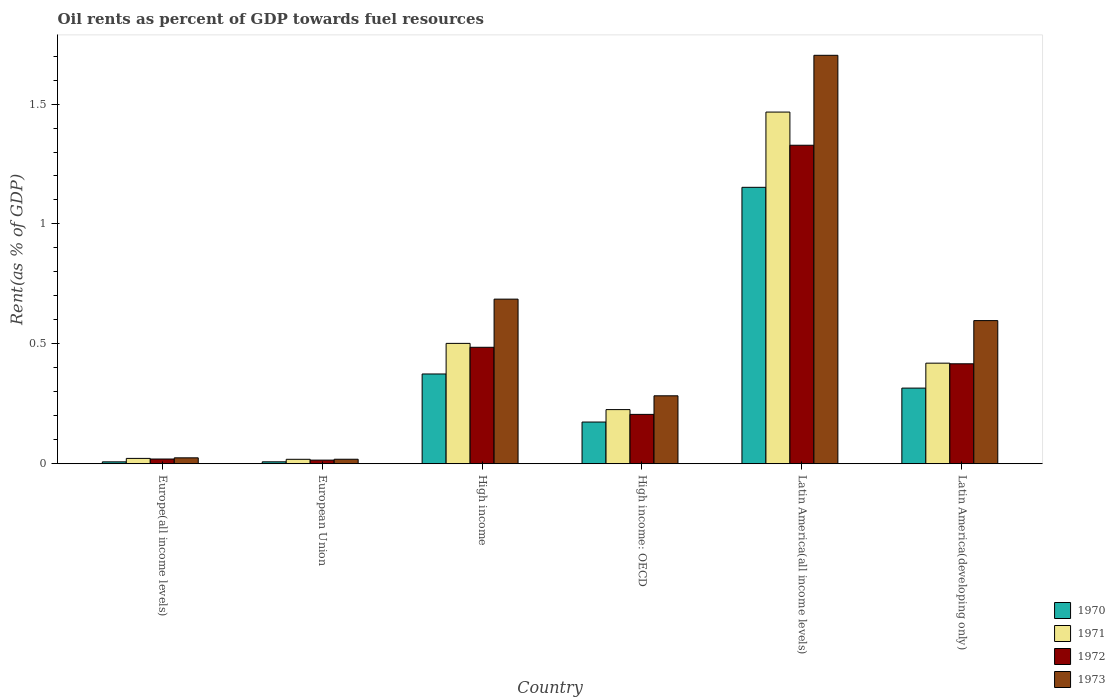How many bars are there on the 4th tick from the left?
Your response must be concise. 4. What is the label of the 1st group of bars from the left?
Offer a very short reply. Europe(all income levels). In how many cases, is the number of bars for a given country not equal to the number of legend labels?
Your answer should be compact. 0. What is the oil rent in 1973 in High income?
Your response must be concise. 0.69. Across all countries, what is the maximum oil rent in 1972?
Provide a short and direct response. 1.33. Across all countries, what is the minimum oil rent in 1973?
Make the answer very short. 0.02. In which country was the oil rent in 1973 maximum?
Give a very brief answer. Latin America(all income levels). In which country was the oil rent in 1973 minimum?
Your answer should be very brief. European Union. What is the total oil rent in 1971 in the graph?
Offer a terse response. 2.65. What is the difference between the oil rent in 1970 in High income: OECD and that in Latin America(developing only)?
Offer a terse response. -0.14. What is the difference between the oil rent in 1973 in Europe(all income levels) and the oil rent in 1970 in European Union?
Ensure brevity in your answer.  0.02. What is the average oil rent in 1970 per country?
Make the answer very short. 0.34. What is the difference between the oil rent of/in 1971 and oil rent of/in 1970 in Latin America(all income levels)?
Provide a short and direct response. 0.31. What is the ratio of the oil rent in 1973 in High income: OECD to that in Latin America(all income levels)?
Keep it short and to the point. 0.17. Is the oil rent in 1971 in European Union less than that in High income: OECD?
Provide a short and direct response. Yes. Is the difference between the oil rent in 1971 in High income and Latin America(all income levels) greater than the difference between the oil rent in 1970 in High income and Latin America(all income levels)?
Provide a short and direct response. No. What is the difference between the highest and the second highest oil rent in 1972?
Offer a terse response. -0.84. What is the difference between the highest and the lowest oil rent in 1970?
Offer a very short reply. 1.14. In how many countries, is the oil rent in 1970 greater than the average oil rent in 1970 taken over all countries?
Provide a short and direct response. 2. Is the sum of the oil rent in 1973 in High income: OECD and Latin America(developing only) greater than the maximum oil rent in 1971 across all countries?
Your answer should be very brief. No. Is it the case that in every country, the sum of the oil rent in 1972 and oil rent in 1970 is greater than the sum of oil rent in 1973 and oil rent in 1971?
Ensure brevity in your answer.  No. What does the 1st bar from the right in European Union represents?
Your answer should be compact. 1973. Is it the case that in every country, the sum of the oil rent in 1970 and oil rent in 1973 is greater than the oil rent in 1972?
Provide a short and direct response. Yes. How many bars are there?
Provide a succinct answer. 24. Are all the bars in the graph horizontal?
Offer a very short reply. No. How many countries are there in the graph?
Give a very brief answer. 6. What is the difference between two consecutive major ticks on the Y-axis?
Ensure brevity in your answer.  0.5. Does the graph contain any zero values?
Your answer should be very brief. No. Where does the legend appear in the graph?
Offer a very short reply. Bottom right. How many legend labels are there?
Your response must be concise. 4. How are the legend labels stacked?
Offer a terse response. Vertical. What is the title of the graph?
Your response must be concise. Oil rents as percent of GDP towards fuel resources. Does "1975" appear as one of the legend labels in the graph?
Offer a very short reply. No. What is the label or title of the X-axis?
Provide a short and direct response. Country. What is the label or title of the Y-axis?
Provide a succinct answer. Rent(as % of GDP). What is the Rent(as % of GDP) in 1970 in Europe(all income levels)?
Ensure brevity in your answer.  0.01. What is the Rent(as % of GDP) in 1971 in Europe(all income levels)?
Keep it short and to the point. 0.02. What is the Rent(as % of GDP) of 1972 in Europe(all income levels)?
Offer a very short reply. 0.02. What is the Rent(as % of GDP) in 1973 in Europe(all income levels)?
Your answer should be very brief. 0.02. What is the Rent(as % of GDP) in 1970 in European Union?
Give a very brief answer. 0.01. What is the Rent(as % of GDP) of 1971 in European Union?
Offer a terse response. 0.02. What is the Rent(as % of GDP) of 1972 in European Union?
Offer a very short reply. 0.02. What is the Rent(as % of GDP) in 1973 in European Union?
Ensure brevity in your answer.  0.02. What is the Rent(as % of GDP) of 1970 in High income?
Provide a short and direct response. 0.37. What is the Rent(as % of GDP) in 1971 in High income?
Provide a short and direct response. 0.5. What is the Rent(as % of GDP) in 1972 in High income?
Your answer should be very brief. 0.49. What is the Rent(as % of GDP) in 1973 in High income?
Offer a terse response. 0.69. What is the Rent(as % of GDP) in 1970 in High income: OECD?
Your response must be concise. 0.17. What is the Rent(as % of GDP) in 1971 in High income: OECD?
Offer a very short reply. 0.23. What is the Rent(as % of GDP) in 1972 in High income: OECD?
Provide a succinct answer. 0.21. What is the Rent(as % of GDP) in 1973 in High income: OECD?
Offer a very short reply. 0.28. What is the Rent(as % of GDP) of 1970 in Latin America(all income levels)?
Your answer should be very brief. 1.15. What is the Rent(as % of GDP) of 1971 in Latin America(all income levels)?
Ensure brevity in your answer.  1.47. What is the Rent(as % of GDP) of 1972 in Latin America(all income levels)?
Keep it short and to the point. 1.33. What is the Rent(as % of GDP) in 1973 in Latin America(all income levels)?
Your answer should be very brief. 1.7. What is the Rent(as % of GDP) of 1970 in Latin America(developing only)?
Provide a short and direct response. 0.32. What is the Rent(as % of GDP) in 1971 in Latin America(developing only)?
Your answer should be very brief. 0.42. What is the Rent(as % of GDP) in 1972 in Latin America(developing only)?
Keep it short and to the point. 0.42. What is the Rent(as % of GDP) in 1973 in Latin America(developing only)?
Offer a terse response. 0.6. Across all countries, what is the maximum Rent(as % of GDP) of 1970?
Offer a very short reply. 1.15. Across all countries, what is the maximum Rent(as % of GDP) of 1971?
Offer a terse response. 1.47. Across all countries, what is the maximum Rent(as % of GDP) in 1972?
Your answer should be very brief. 1.33. Across all countries, what is the maximum Rent(as % of GDP) of 1973?
Provide a succinct answer. 1.7. Across all countries, what is the minimum Rent(as % of GDP) in 1970?
Make the answer very short. 0.01. Across all countries, what is the minimum Rent(as % of GDP) in 1971?
Offer a terse response. 0.02. Across all countries, what is the minimum Rent(as % of GDP) of 1972?
Give a very brief answer. 0.02. Across all countries, what is the minimum Rent(as % of GDP) in 1973?
Your answer should be compact. 0.02. What is the total Rent(as % of GDP) of 1970 in the graph?
Your answer should be very brief. 2.03. What is the total Rent(as % of GDP) of 1971 in the graph?
Provide a short and direct response. 2.65. What is the total Rent(as % of GDP) of 1972 in the graph?
Provide a succinct answer. 2.47. What is the total Rent(as % of GDP) of 1973 in the graph?
Your answer should be very brief. 3.31. What is the difference between the Rent(as % of GDP) of 1970 in Europe(all income levels) and that in European Union?
Make the answer very short. -0. What is the difference between the Rent(as % of GDP) in 1971 in Europe(all income levels) and that in European Union?
Offer a very short reply. 0. What is the difference between the Rent(as % of GDP) in 1972 in Europe(all income levels) and that in European Union?
Provide a short and direct response. 0. What is the difference between the Rent(as % of GDP) of 1973 in Europe(all income levels) and that in European Union?
Provide a succinct answer. 0.01. What is the difference between the Rent(as % of GDP) of 1970 in Europe(all income levels) and that in High income?
Keep it short and to the point. -0.37. What is the difference between the Rent(as % of GDP) in 1971 in Europe(all income levels) and that in High income?
Make the answer very short. -0.48. What is the difference between the Rent(as % of GDP) in 1972 in Europe(all income levels) and that in High income?
Your answer should be very brief. -0.47. What is the difference between the Rent(as % of GDP) of 1973 in Europe(all income levels) and that in High income?
Your answer should be compact. -0.66. What is the difference between the Rent(as % of GDP) of 1970 in Europe(all income levels) and that in High income: OECD?
Your response must be concise. -0.17. What is the difference between the Rent(as % of GDP) in 1971 in Europe(all income levels) and that in High income: OECD?
Keep it short and to the point. -0.2. What is the difference between the Rent(as % of GDP) in 1972 in Europe(all income levels) and that in High income: OECD?
Offer a terse response. -0.19. What is the difference between the Rent(as % of GDP) of 1973 in Europe(all income levels) and that in High income: OECD?
Make the answer very short. -0.26. What is the difference between the Rent(as % of GDP) of 1970 in Europe(all income levels) and that in Latin America(all income levels)?
Make the answer very short. -1.14. What is the difference between the Rent(as % of GDP) of 1971 in Europe(all income levels) and that in Latin America(all income levels)?
Your answer should be compact. -1.44. What is the difference between the Rent(as % of GDP) of 1972 in Europe(all income levels) and that in Latin America(all income levels)?
Your answer should be very brief. -1.31. What is the difference between the Rent(as % of GDP) in 1973 in Europe(all income levels) and that in Latin America(all income levels)?
Your response must be concise. -1.68. What is the difference between the Rent(as % of GDP) of 1970 in Europe(all income levels) and that in Latin America(developing only)?
Keep it short and to the point. -0.31. What is the difference between the Rent(as % of GDP) of 1971 in Europe(all income levels) and that in Latin America(developing only)?
Provide a short and direct response. -0.4. What is the difference between the Rent(as % of GDP) of 1972 in Europe(all income levels) and that in Latin America(developing only)?
Provide a short and direct response. -0.4. What is the difference between the Rent(as % of GDP) of 1973 in Europe(all income levels) and that in Latin America(developing only)?
Make the answer very short. -0.57. What is the difference between the Rent(as % of GDP) of 1970 in European Union and that in High income?
Make the answer very short. -0.37. What is the difference between the Rent(as % of GDP) in 1971 in European Union and that in High income?
Provide a short and direct response. -0.48. What is the difference between the Rent(as % of GDP) in 1972 in European Union and that in High income?
Give a very brief answer. -0.47. What is the difference between the Rent(as % of GDP) of 1973 in European Union and that in High income?
Provide a short and direct response. -0.67. What is the difference between the Rent(as % of GDP) of 1970 in European Union and that in High income: OECD?
Keep it short and to the point. -0.17. What is the difference between the Rent(as % of GDP) of 1971 in European Union and that in High income: OECD?
Ensure brevity in your answer.  -0.21. What is the difference between the Rent(as % of GDP) of 1972 in European Union and that in High income: OECD?
Offer a terse response. -0.19. What is the difference between the Rent(as % of GDP) of 1973 in European Union and that in High income: OECD?
Give a very brief answer. -0.26. What is the difference between the Rent(as % of GDP) of 1970 in European Union and that in Latin America(all income levels)?
Make the answer very short. -1.14. What is the difference between the Rent(as % of GDP) in 1971 in European Union and that in Latin America(all income levels)?
Provide a succinct answer. -1.45. What is the difference between the Rent(as % of GDP) of 1972 in European Union and that in Latin America(all income levels)?
Offer a very short reply. -1.31. What is the difference between the Rent(as % of GDP) of 1973 in European Union and that in Latin America(all income levels)?
Give a very brief answer. -1.68. What is the difference between the Rent(as % of GDP) of 1970 in European Union and that in Latin America(developing only)?
Provide a short and direct response. -0.31. What is the difference between the Rent(as % of GDP) in 1971 in European Union and that in Latin America(developing only)?
Your answer should be compact. -0.4. What is the difference between the Rent(as % of GDP) of 1972 in European Union and that in Latin America(developing only)?
Provide a short and direct response. -0.4. What is the difference between the Rent(as % of GDP) in 1973 in European Union and that in Latin America(developing only)?
Your response must be concise. -0.58. What is the difference between the Rent(as % of GDP) in 1970 in High income and that in High income: OECD?
Provide a succinct answer. 0.2. What is the difference between the Rent(as % of GDP) of 1971 in High income and that in High income: OECD?
Provide a short and direct response. 0.28. What is the difference between the Rent(as % of GDP) of 1972 in High income and that in High income: OECD?
Make the answer very short. 0.28. What is the difference between the Rent(as % of GDP) of 1973 in High income and that in High income: OECD?
Your answer should be compact. 0.4. What is the difference between the Rent(as % of GDP) in 1970 in High income and that in Latin America(all income levels)?
Your answer should be compact. -0.78. What is the difference between the Rent(as % of GDP) of 1971 in High income and that in Latin America(all income levels)?
Provide a succinct answer. -0.96. What is the difference between the Rent(as % of GDP) in 1972 in High income and that in Latin America(all income levels)?
Give a very brief answer. -0.84. What is the difference between the Rent(as % of GDP) of 1973 in High income and that in Latin America(all income levels)?
Offer a terse response. -1.02. What is the difference between the Rent(as % of GDP) of 1970 in High income and that in Latin America(developing only)?
Provide a succinct answer. 0.06. What is the difference between the Rent(as % of GDP) of 1971 in High income and that in Latin America(developing only)?
Ensure brevity in your answer.  0.08. What is the difference between the Rent(as % of GDP) of 1972 in High income and that in Latin America(developing only)?
Your answer should be compact. 0.07. What is the difference between the Rent(as % of GDP) of 1973 in High income and that in Latin America(developing only)?
Make the answer very short. 0.09. What is the difference between the Rent(as % of GDP) in 1970 in High income: OECD and that in Latin America(all income levels)?
Keep it short and to the point. -0.98. What is the difference between the Rent(as % of GDP) of 1971 in High income: OECD and that in Latin America(all income levels)?
Make the answer very short. -1.24. What is the difference between the Rent(as % of GDP) of 1972 in High income: OECD and that in Latin America(all income levels)?
Keep it short and to the point. -1.12. What is the difference between the Rent(as % of GDP) in 1973 in High income: OECD and that in Latin America(all income levels)?
Ensure brevity in your answer.  -1.42. What is the difference between the Rent(as % of GDP) of 1970 in High income: OECD and that in Latin America(developing only)?
Offer a terse response. -0.14. What is the difference between the Rent(as % of GDP) of 1971 in High income: OECD and that in Latin America(developing only)?
Your answer should be compact. -0.19. What is the difference between the Rent(as % of GDP) of 1972 in High income: OECD and that in Latin America(developing only)?
Provide a short and direct response. -0.21. What is the difference between the Rent(as % of GDP) in 1973 in High income: OECD and that in Latin America(developing only)?
Ensure brevity in your answer.  -0.31. What is the difference between the Rent(as % of GDP) of 1970 in Latin America(all income levels) and that in Latin America(developing only)?
Provide a short and direct response. 0.84. What is the difference between the Rent(as % of GDP) of 1971 in Latin America(all income levels) and that in Latin America(developing only)?
Your answer should be very brief. 1.05. What is the difference between the Rent(as % of GDP) in 1972 in Latin America(all income levels) and that in Latin America(developing only)?
Give a very brief answer. 0.91. What is the difference between the Rent(as % of GDP) in 1973 in Latin America(all income levels) and that in Latin America(developing only)?
Your answer should be compact. 1.11. What is the difference between the Rent(as % of GDP) in 1970 in Europe(all income levels) and the Rent(as % of GDP) in 1971 in European Union?
Your answer should be very brief. -0.01. What is the difference between the Rent(as % of GDP) in 1970 in Europe(all income levels) and the Rent(as % of GDP) in 1972 in European Union?
Provide a short and direct response. -0.01. What is the difference between the Rent(as % of GDP) in 1970 in Europe(all income levels) and the Rent(as % of GDP) in 1973 in European Union?
Keep it short and to the point. -0.01. What is the difference between the Rent(as % of GDP) in 1971 in Europe(all income levels) and the Rent(as % of GDP) in 1972 in European Union?
Your answer should be very brief. 0.01. What is the difference between the Rent(as % of GDP) in 1971 in Europe(all income levels) and the Rent(as % of GDP) in 1973 in European Union?
Give a very brief answer. 0. What is the difference between the Rent(as % of GDP) of 1972 in Europe(all income levels) and the Rent(as % of GDP) of 1973 in European Union?
Offer a terse response. 0. What is the difference between the Rent(as % of GDP) of 1970 in Europe(all income levels) and the Rent(as % of GDP) of 1971 in High income?
Provide a short and direct response. -0.49. What is the difference between the Rent(as % of GDP) in 1970 in Europe(all income levels) and the Rent(as % of GDP) in 1972 in High income?
Offer a very short reply. -0.48. What is the difference between the Rent(as % of GDP) in 1970 in Europe(all income levels) and the Rent(as % of GDP) in 1973 in High income?
Your response must be concise. -0.68. What is the difference between the Rent(as % of GDP) of 1971 in Europe(all income levels) and the Rent(as % of GDP) of 1972 in High income?
Make the answer very short. -0.46. What is the difference between the Rent(as % of GDP) of 1971 in Europe(all income levels) and the Rent(as % of GDP) of 1973 in High income?
Offer a terse response. -0.66. What is the difference between the Rent(as % of GDP) of 1972 in Europe(all income levels) and the Rent(as % of GDP) of 1973 in High income?
Provide a short and direct response. -0.67. What is the difference between the Rent(as % of GDP) in 1970 in Europe(all income levels) and the Rent(as % of GDP) in 1971 in High income: OECD?
Provide a succinct answer. -0.22. What is the difference between the Rent(as % of GDP) in 1970 in Europe(all income levels) and the Rent(as % of GDP) in 1972 in High income: OECD?
Your answer should be very brief. -0.2. What is the difference between the Rent(as % of GDP) in 1970 in Europe(all income levels) and the Rent(as % of GDP) in 1973 in High income: OECD?
Ensure brevity in your answer.  -0.28. What is the difference between the Rent(as % of GDP) of 1971 in Europe(all income levels) and the Rent(as % of GDP) of 1972 in High income: OECD?
Provide a short and direct response. -0.18. What is the difference between the Rent(as % of GDP) in 1971 in Europe(all income levels) and the Rent(as % of GDP) in 1973 in High income: OECD?
Provide a succinct answer. -0.26. What is the difference between the Rent(as % of GDP) of 1972 in Europe(all income levels) and the Rent(as % of GDP) of 1973 in High income: OECD?
Provide a succinct answer. -0.26. What is the difference between the Rent(as % of GDP) of 1970 in Europe(all income levels) and the Rent(as % of GDP) of 1971 in Latin America(all income levels)?
Offer a very short reply. -1.46. What is the difference between the Rent(as % of GDP) of 1970 in Europe(all income levels) and the Rent(as % of GDP) of 1972 in Latin America(all income levels)?
Your answer should be compact. -1.32. What is the difference between the Rent(as % of GDP) of 1970 in Europe(all income levels) and the Rent(as % of GDP) of 1973 in Latin America(all income levels)?
Offer a very short reply. -1.7. What is the difference between the Rent(as % of GDP) in 1971 in Europe(all income levels) and the Rent(as % of GDP) in 1972 in Latin America(all income levels)?
Provide a short and direct response. -1.31. What is the difference between the Rent(as % of GDP) of 1971 in Europe(all income levels) and the Rent(as % of GDP) of 1973 in Latin America(all income levels)?
Your response must be concise. -1.68. What is the difference between the Rent(as % of GDP) of 1972 in Europe(all income levels) and the Rent(as % of GDP) of 1973 in Latin America(all income levels)?
Give a very brief answer. -1.68. What is the difference between the Rent(as % of GDP) of 1970 in Europe(all income levels) and the Rent(as % of GDP) of 1971 in Latin America(developing only)?
Provide a short and direct response. -0.41. What is the difference between the Rent(as % of GDP) of 1970 in Europe(all income levels) and the Rent(as % of GDP) of 1972 in Latin America(developing only)?
Ensure brevity in your answer.  -0.41. What is the difference between the Rent(as % of GDP) of 1970 in Europe(all income levels) and the Rent(as % of GDP) of 1973 in Latin America(developing only)?
Provide a short and direct response. -0.59. What is the difference between the Rent(as % of GDP) in 1971 in Europe(all income levels) and the Rent(as % of GDP) in 1972 in Latin America(developing only)?
Your answer should be compact. -0.39. What is the difference between the Rent(as % of GDP) of 1971 in Europe(all income levels) and the Rent(as % of GDP) of 1973 in Latin America(developing only)?
Ensure brevity in your answer.  -0.57. What is the difference between the Rent(as % of GDP) in 1972 in Europe(all income levels) and the Rent(as % of GDP) in 1973 in Latin America(developing only)?
Offer a very short reply. -0.58. What is the difference between the Rent(as % of GDP) of 1970 in European Union and the Rent(as % of GDP) of 1971 in High income?
Offer a terse response. -0.49. What is the difference between the Rent(as % of GDP) of 1970 in European Union and the Rent(as % of GDP) of 1972 in High income?
Your answer should be compact. -0.48. What is the difference between the Rent(as % of GDP) of 1970 in European Union and the Rent(as % of GDP) of 1973 in High income?
Make the answer very short. -0.68. What is the difference between the Rent(as % of GDP) in 1971 in European Union and the Rent(as % of GDP) in 1972 in High income?
Offer a terse response. -0.47. What is the difference between the Rent(as % of GDP) of 1971 in European Union and the Rent(as % of GDP) of 1973 in High income?
Provide a succinct answer. -0.67. What is the difference between the Rent(as % of GDP) in 1972 in European Union and the Rent(as % of GDP) in 1973 in High income?
Ensure brevity in your answer.  -0.67. What is the difference between the Rent(as % of GDP) of 1970 in European Union and the Rent(as % of GDP) of 1971 in High income: OECD?
Provide a short and direct response. -0.22. What is the difference between the Rent(as % of GDP) of 1970 in European Union and the Rent(as % of GDP) of 1972 in High income: OECD?
Give a very brief answer. -0.2. What is the difference between the Rent(as % of GDP) of 1970 in European Union and the Rent(as % of GDP) of 1973 in High income: OECD?
Your answer should be very brief. -0.28. What is the difference between the Rent(as % of GDP) in 1971 in European Union and the Rent(as % of GDP) in 1972 in High income: OECD?
Offer a very short reply. -0.19. What is the difference between the Rent(as % of GDP) in 1971 in European Union and the Rent(as % of GDP) in 1973 in High income: OECD?
Ensure brevity in your answer.  -0.26. What is the difference between the Rent(as % of GDP) of 1972 in European Union and the Rent(as % of GDP) of 1973 in High income: OECD?
Your answer should be compact. -0.27. What is the difference between the Rent(as % of GDP) of 1970 in European Union and the Rent(as % of GDP) of 1971 in Latin America(all income levels)?
Keep it short and to the point. -1.46. What is the difference between the Rent(as % of GDP) in 1970 in European Union and the Rent(as % of GDP) in 1972 in Latin America(all income levels)?
Your answer should be very brief. -1.32. What is the difference between the Rent(as % of GDP) in 1970 in European Union and the Rent(as % of GDP) in 1973 in Latin America(all income levels)?
Provide a succinct answer. -1.7. What is the difference between the Rent(as % of GDP) of 1971 in European Union and the Rent(as % of GDP) of 1972 in Latin America(all income levels)?
Your answer should be very brief. -1.31. What is the difference between the Rent(as % of GDP) of 1971 in European Union and the Rent(as % of GDP) of 1973 in Latin America(all income levels)?
Your response must be concise. -1.68. What is the difference between the Rent(as % of GDP) of 1972 in European Union and the Rent(as % of GDP) of 1973 in Latin America(all income levels)?
Offer a terse response. -1.69. What is the difference between the Rent(as % of GDP) in 1970 in European Union and the Rent(as % of GDP) in 1971 in Latin America(developing only)?
Offer a very short reply. -0.41. What is the difference between the Rent(as % of GDP) in 1970 in European Union and the Rent(as % of GDP) in 1972 in Latin America(developing only)?
Provide a succinct answer. -0.41. What is the difference between the Rent(as % of GDP) in 1970 in European Union and the Rent(as % of GDP) in 1973 in Latin America(developing only)?
Make the answer very short. -0.59. What is the difference between the Rent(as % of GDP) of 1971 in European Union and the Rent(as % of GDP) of 1972 in Latin America(developing only)?
Provide a succinct answer. -0.4. What is the difference between the Rent(as % of GDP) in 1971 in European Union and the Rent(as % of GDP) in 1973 in Latin America(developing only)?
Your answer should be compact. -0.58. What is the difference between the Rent(as % of GDP) of 1972 in European Union and the Rent(as % of GDP) of 1973 in Latin America(developing only)?
Give a very brief answer. -0.58. What is the difference between the Rent(as % of GDP) in 1970 in High income and the Rent(as % of GDP) in 1971 in High income: OECD?
Keep it short and to the point. 0.15. What is the difference between the Rent(as % of GDP) in 1970 in High income and the Rent(as % of GDP) in 1972 in High income: OECD?
Your response must be concise. 0.17. What is the difference between the Rent(as % of GDP) of 1970 in High income and the Rent(as % of GDP) of 1973 in High income: OECD?
Keep it short and to the point. 0.09. What is the difference between the Rent(as % of GDP) in 1971 in High income and the Rent(as % of GDP) in 1972 in High income: OECD?
Provide a succinct answer. 0.3. What is the difference between the Rent(as % of GDP) in 1971 in High income and the Rent(as % of GDP) in 1973 in High income: OECD?
Ensure brevity in your answer.  0.22. What is the difference between the Rent(as % of GDP) in 1972 in High income and the Rent(as % of GDP) in 1973 in High income: OECD?
Your answer should be very brief. 0.2. What is the difference between the Rent(as % of GDP) of 1970 in High income and the Rent(as % of GDP) of 1971 in Latin America(all income levels)?
Your response must be concise. -1.09. What is the difference between the Rent(as % of GDP) of 1970 in High income and the Rent(as % of GDP) of 1972 in Latin America(all income levels)?
Offer a terse response. -0.95. What is the difference between the Rent(as % of GDP) in 1970 in High income and the Rent(as % of GDP) in 1973 in Latin America(all income levels)?
Offer a very short reply. -1.33. What is the difference between the Rent(as % of GDP) of 1971 in High income and the Rent(as % of GDP) of 1972 in Latin America(all income levels)?
Offer a very short reply. -0.83. What is the difference between the Rent(as % of GDP) of 1971 in High income and the Rent(as % of GDP) of 1973 in Latin America(all income levels)?
Provide a short and direct response. -1.2. What is the difference between the Rent(as % of GDP) of 1972 in High income and the Rent(as % of GDP) of 1973 in Latin America(all income levels)?
Provide a succinct answer. -1.22. What is the difference between the Rent(as % of GDP) of 1970 in High income and the Rent(as % of GDP) of 1971 in Latin America(developing only)?
Keep it short and to the point. -0.05. What is the difference between the Rent(as % of GDP) in 1970 in High income and the Rent(as % of GDP) in 1972 in Latin America(developing only)?
Make the answer very short. -0.04. What is the difference between the Rent(as % of GDP) in 1970 in High income and the Rent(as % of GDP) in 1973 in Latin America(developing only)?
Your answer should be very brief. -0.22. What is the difference between the Rent(as % of GDP) of 1971 in High income and the Rent(as % of GDP) of 1972 in Latin America(developing only)?
Keep it short and to the point. 0.09. What is the difference between the Rent(as % of GDP) in 1971 in High income and the Rent(as % of GDP) in 1973 in Latin America(developing only)?
Keep it short and to the point. -0.1. What is the difference between the Rent(as % of GDP) in 1972 in High income and the Rent(as % of GDP) in 1973 in Latin America(developing only)?
Give a very brief answer. -0.11. What is the difference between the Rent(as % of GDP) of 1970 in High income: OECD and the Rent(as % of GDP) of 1971 in Latin America(all income levels)?
Offer a very short reply. -1.29. What is the difference between the Rent(as % of GDP) in 1970 in High income: OECD and the Rent(as % of GDP) in 1972 in Latin America(all income levels)?
Your answer should be very brief. -1.15. What is the difference between the Rent(as % of GDP) in 1970 in High income: OECD and the Rent(as % of GDP) in 1973 in Latin America(all income levels)?
Keep it short and to the point. -1.53. What is the difference between the Rent(as % of GDP) in 1971 in High income: OECD and the Rent(as % of GDP) in 1972 in Latin America(all income levels)?
Make the answer very short. -1.1. What is the difference between the Rent(as % of GDP) of 1971 in High income: OECD and the Rent(as % of GDP) of 1973 in Latin America(all income levels)?
Your answer should be very brief. -1.48. What is the difference between the Rent(as % of GDP) of 1972 in High income: OECD and the Rent(as % of GDP) of 1973 in Latin America(all income levels)?
Provide a short and direct response. -1.5. What is the difference between the Rent(as % of GDP) in 1970 in High income: OECD and the Rent(as % of GDP) in 1971 in Latin America(developing only)?
Your response must be concise. -0.25. What is the difference between the Rent(as % of GDP) of 1970 in High income: OECD and the Rent(as % of GDP) of 1972 in Latin America(developing only)?
Your answer should be compact. -0.24. What is the difference between the Rent(as % of GDP) of 1970 in High income: OECD and the Rent(as % of GDP) of 1973 in Latin America(developing only)?
Your response must be concise. -0.42. What is the difference between the Rent(as % of GDP) in 1971 in High income: OECD and the Rent(as % of GDP) in 1972 in Latin America(developing only)?
Offer a very short reply. -0.19. What is the difference between the Rent(as % of GDP) of 1971 in High income: OECD and the Rent(as % of GDP) of 1973 in Latin America(developing only)?
Give a very brief answer. -0.37. What is the difference between the Rent(as % of GDP) of 1972 in High income: OECD and the Rent(as % of GDP) of 1973 in Latin America(developing only)?
Your answer should be compact. -0.39. What is the difference between the Rent(as % of GDP) in 1970 in Latin America(all income levels) and the Rent(as % of GDP) in 1971 in Latin America(developing only)?
Your response must be concise. 0.73. What is the difference between the Rent(as % of GDP) of 1970 in Latin America(all income levels) and the Rent(as % of GDP) of 1972 in Latin America(developing only)?
Offer a very short reply. 0.74. What is the difference between the Rent(as % of GDP) in 1970 in Latin America(all income levels) and the Rent(as % of GDP) in 1973 in Latin America(developing only)?
Offer a very short reply. 0.56. What is the difference between the Rent(as % of GDP) in 1971 in Latin America(all income levels) and the Rent(as % of GDP) in 1972 in Latin America(developing only)?
Offer a very short reply. 1.05. What is the difference between the Rent(as % of GDP) of 1971 in Latin America(all income levels) and the Rent(as % of GDP) of 1973 in Latin America(developing only)?
Give a very brief answer. 0.87. What is the difference between the Rent(as % of GDP) of 1972 in Latin America(all income levels) and the Rent(as % of GDP) of 1973 in Latin America(developing only)?
Give a very brief answer. 0.73. What is the average Rent(as % of GDP) in 1970 per country?
Offer a very short reply. 0.34. What is the average Rent(as % of GDP) in 1971 per country?
Give a very brief answer. 0.44. What is the average Rent(as % of GDP) in 1972 per country?
Keep it short and to the point. 0.41. What is the average Rent(as % of GDP) in 1973 per country?
Offer a terse response. 0.55. What is the difference between the Rent(as % of GDP) of 1970 and Rent(as % of GDP) of 1971 in Europe(all income levels)?
Provide a succinct answer. -0.01. What is the difference between the Rent(as % of GDP) of 1970 and Rent(as % of GDP) of 1972 in Europe(all income levels)?
Give a very brief answer. -0.01. What is the difference between the Rent(as % of GDP) in 1970 and Rent(as % of GDP) in 1973 in Europe(all income levels)?
Make the answer very short. -0.02. What is the difference between the Rent(as % of GDP) of 1971 and Rent(as % of GDP) of 1972 in Europe(all income levels)?
Your answer should be very brief. 0. What is the difference between the Rent(as % of GDP) of 1971 and Rent(as % of GDP) of 1973 in Europe(all income levels)?
Offer a terse response. -0. What is the difference between the Rent(as % of GDP) of 1972 and Rent(as % of GDP) of 1973 in Europe(all income levels)?
Provide a short and direct response. -0.01. What is the difference between the Rent(as % of GDP) in 1970 and Rent(as % of GDP) in 1971 in European Union?
Keep it short and to the point. -0.01. What is the difference between the Rent(as % of GDP) in 1970 and Rent(as % of GDP) in 1972 in European Union?
Offer a very short reply. -0.01. What is the difference between the Rent(as % of GDP) of 1970 and Rent(as % of GDP) of 1973 in European Union?
Ensure brevity in your answer.  -0.01. What is the difference between the Rent(as % of GDP) in 1971 and Rent(as % of GDP) in 1972 in European Union?
Your answer should be very brief. 0. What is the difference between the Rent(as % of GDP) of 1971 and Rent(as % of GDP) of 1973 in European Union?
Ensure brevity in your answer.  -0. What is the difference between the Rent(as % of GDP) of 1972 and Rent(as % of GDP) of 1973 in European Union?
Your answer should be compact. -0. What is the difference between the Rent(as % of GDP) in 1970 and Rent(as % of GDP) in 1971 in High income?
Provide a succinct answer. -0.13. What is the difference between the Rent(as % of GDP) in 1970 and Rent(as % of GDP) in 1972 in High income?
Make the answer very short. -0.11. What is the difference between the Rent(as % of GDP) of 1970 and Rent(as % of GDP) of 1973 in High income?
Ensure brevity in your answer.  -0.31. What is the difference between the Rent(as % of GDP) in 1971 and Rent(as % of GDP) in 1972 in High income?
Give a very brief answer. 0.02. What is the difference between the Rent(as % of GDP) of 1971 and Rent(as % of GDP) of 1973 in High income?
Provide a succinct answer. -0.18. What is the difference between the Rent(as % of GDP) in 1972 and Rent(as % of GDP) in 1973 in High income?
Offer a terse response. -0.2. What is the difference between the Rent(as % of GDP) in 1970 and Rent(as % of GDP) in 1971 in High income: OECD?
Provide a succinct answer. -0.05. What is the difference between the Rent(as % of GDP) of 1970 and Rent(as % of GDP) of 1972 in High income: OECD?
Your response must be concise. -0.03. What is the difference between the Rent(as % of GDP) of 1970 and Rent(as % of GDP) of 1973 in High income: OECD?
Provide a succinct answer. -0.11. What is the difference between the Rent(as % of GDP) of 1971 and Rent(as % of GDP) of 1973 in High income: OECD?
Your response must be concise. -0.06. What is the difference between the Rent(as % of GDP) in 1972 and Rent(as % of GDP) in 1973 in High income: OECD?
Provide a short and direct response. -0.08. What is the difference between the Rent(as % of GDP) in 1970 and Rent(as % of GDP) in 1971 in Latin America(all income levels)?
Offer a terse response. -0.31. What is the difference between the Rent(as % of GDP) of 1970 and Rent(as % of GDP) of 1972 in Latin America(all income levels)?
Make the answer very short. -0.18. What is the difference between the Rent(as % of GDP) in 1970 and Rent(as % of GDP) in 1973 in Latin America(all income levels)?
Offer a very short reply. -0.55. What is the difference between the Rent(as % of GDP) in 1971 and Rent(as % of GDP) in 1972 in Latin America(all income levels)?
Keep it short and to the point. 0.14. What is the difference between the Rent(as % of GDP) in 1971 and Rent(as % of GDP) in 1973 in Latin America(all income levels)?
Make the answer very short. -0.24. What is the difference between the Rent(as % of GDP) in 1972 and Rent(as % of GDP) in 1973 in Latin America(all income levels)?
Offer a terse response. -0.38. What is the difference between the Rent(as % of GDP) of 1970 and Rent(as % of GDP) of 1971 in Latin America(developing only)?
Make the answer very short. -0.1. What is the difference between the Rent(as % of GDP) in 1970 and Rent(as % of GDP) in 1972 in Latin America(developing only)?
Ensure brevity in your answer.  -0.1. What is the difference between the Rent(as % of GDP) in 1970 and Rent(as % of GDP) in 1973 in Latin America(developing only)?
Your response must be concise. -0.28. What is the difference between the Rent(as % of GDP) of 1971 and Rent(as % of GDP) of 1972 in Latin America(developing only)?
Provide a succinct answer. 0. What is the difference between the Rent(as % of GDP) of 1971 and Rent(as % of GDP) of 1973 in Latin America(developing only)?
Offer a terse response. -0.18. What is the difference between the Rent(as % of GDP) of 1972 and Rent(as % of GDP) of 1973 in Latin America(developing only)?
Provide a short and direct response. -0.18. What is the ratio of the Rent(as % of GDP) in 1970 in Europe(all income levels) to that in European Union?
Give a very brief answer. 0.98. What is the ratio of the Rent(as % of GDP) in 1971 in Europe(all income levels) to that in European Union?
Your response must be concise. 1.2. What is the ratio of the Rent(as % of GDP) of 1972 in Europe(all income levels) to that in European Union?
Give a very brief answer. 1.3. What is the ratio of the Rent(as % of GDP) of 1973 in Europe(all income levels) to that in European Union?
Offer a very short reply. 1.31. What is the ratio of the Rent(as % of GDP) of 1970 in Europe(all income levels) to that in High income?
Keep it short and to the point. 0.02. What is the ratio of the Rent(as % of GDP) in 1971 in Europe(all income levels) to that in High income?
Offer a terse response. 0.04. What is the ratio of the Rent(as % of GDP) in 1972 in Europe(all income levels) to that in High income?
Ensure brevity in your answer.  0.04. What is the ratio of the Rent(as % of GDP) of 1973 in Europe(all income levels) to that in High income?
Your answer should be compact. 0.04. What is the ratio of the Rent(as % of GDP) in 1970 in Europe(all income levels) to that in High income: OECD?
Your answer should be compact. 0.05. What is the ratio of the Rent(as % of GDP) of 1971 in Europe(all income levels) to that in High income: OECD?
Give a very brief answer. 0.1. What is the ratio of the Rent(as % of GDP) of 1972 in Europe(all income levels) to that in High income: OECD?
Provide a succinct answer. 0.1. What is the ratio of the Rent(as % of GDP) in 1973 in Europe(all income levels) to that in High income: OECD?
Offer a very short reply. 0.09. What is the ratio of the Rent(as % of GDP) of 1970 in Europe(all income levels) to that in Latin America(all income levels)?
Offer a terse response. 0.01. What is the ratio of the Rent(as % of GDP) in 1971 in Europe(all income levels) to that in Latin America(all income levels)?
Your answer should be very brief. 0.02. What is the ratio of the Rent(as % of GDP) of 1972 in Europe(all income levels) to that in Latin America(all income levels)?
Offer a very short reply. 0.01. What is the ratio of the Rent(as % of GDP) in 1973 in Europe(all income levels) to that in Latin America(all income levels)?
Offer a terse response. 0.01. What is the ratio of the Rent(as % of GDP) in 1970 in Europe(all income levels) to that in Latin America(developing only)?
Keep it short and to the point. 0.02. What is the ratio of the Rent(as % of GDP) of 1971 in Europe(all income levels) to that in Latin America(developing only)?
Make the answer very short. 0.05. What is the ratio of the Rent(as % of GDP) of 1972 in Europe(all income levels) to that in Latin America(developing only)?
Offer a terse response. 0.05. What is the ratio of the Rent(as % of GDP) of 1973 in Europe(all income levels) to that in Latin America(developing only)?
Ensure brevity in your answer.  0.04. What is the ratio of the Rent(as % of GDP) in 1970 in European Union to that in High income?
Your answer should be compact. 0.02. What is the ratio of the Rent(as % of GDP) of 1971 in European Union to that in High income?
Make the answer very short. 0.04. What is the ratio of the Rent(as % of GDP) of 1972 in European Union to that in High income?
Your answer should be very brief. 0.03. What is the ratio of the Rent(as % of GDP) in 1973 in European Union to that in High income?
Your response must be concise. 0.03. What is the ratio of the Rent(as % of GDP) of 1970 in European Union to that in High income: OECD?
Give a very brief answer. 0.05. What is the ratio of the Rent(as % of GDP) in 1971 in European Union to that in High income: OECD?
Your answer should be very brief. 0.08. What is the ratio of the Rent(as % of GDP) of 1972 in European Union to that in High income: OECD?
Your answer should be compact. 0.07. What is the ratio of the Rent(as % of GDP) in 1973 in European Union to that in High income: OECD?
Keep it short and to the point. 0.07. What is the ratio of the Rent(as % of GDP) of 1970 in European Union to that in Latin America(all income levels)?
Your response must be concise. 0.01. What is the ratio of the Rent(as % of GDP) in 1971 in European Union to that in Latin America(all income levels)?
Offer a terse response. 0.01. What is the ratio of the Rent(as % of GDP) in 1972 in European Union to that in Latin America(all income levels)?
Make the answer very short. 0.01. What is the ratio of the Rent(as % of GDP) of 1973 in European Union to that in Latin America(all income levels)?
Keep it short and to the point. 0.01. What is the ratio of the Rent(as % of GDP) of 1970 in European Union to that in Latin America(developing only)?
Your response must be concise. 0.03. What is the ratio of the Rent(as % of GDP) in 1971 in European Union to that in Latin America(developing only)?
Offer a very short reply. 0.04. What is the ratio of the Rent(as % of GDP) of 1972 in European Union to that in Latin America(developing only)?
Ensure brevity in your answer.  0.04. What is the ratio of the Rent(as % of GDP) in 1973 in European Union to that in Latin America(developing only)?
Give a very brief answer. 0.03. What is the ratio of the Rent(as % of GDP) in 1970 in High income to that in High income: OECD?
Offer a terse response. 2.15. What is the ratio of the Rent(as % of GDP) of 1971 in High income to that in High income: OECD?
Your answer should be compact. 2.22. What is the ratio of the Rent(as % of GDP) of 1972 in High income to that in High income: OECD?
Offer a terse response. 2.36. What is the ratio of the Rent(as % of GDP) of 1973 in High income to that in High income: OECD?
Keep it short and to the point. 2.42. What is the ratio of the Rent(as % of GDP) of 1970 in High income to that in Latin America(all income levels)?
Offer a terse response. 0.32. What is the ratio of the Rent(as % of GDP) of 1971 in High income to that in Latin America(all income levels)?
Ensure brevity in your answer.  0.34. What is the ratio of the Rent(as % of GDP) in 1972 in High income to that in Latin America(all income levels)?
Ensure brevity in your answer.  0.37. What is the ratio of the Rent(as % of GDP) in 1973 in High income to that in Latin America(all income levels)?
Your answer should be compact. 0.4. What is the ratio of the Rent(as % of GDP) in 1970 in High income to that in Latin America(developing only)?
Your answer should be very brief. 1.19. What is the ratio of the Rent(as % of GDP) in 1971 in High income to that in Latin America(developing only)?
Ensure brevity in your answer.  1.2. What is the ratio of the Rent(as % of GDP) of 1972 in High income to that in Latin America(developing only)?
Ensure brevity in your answer.  1.17. What is the ratio of the Rent(as % of GDP) of 1973 in High income to that in Latin America(developing only)?
Your response must be concise. 1.15. What is the ratio of the Rent(as % of GDP) of 1970 in High income: OECD to that in Latin America(all income levels)?
Keep it short and to the point. 0.15. What is the ratio of the Rent(as % of GDP) of 1971 in High income: OECD to that in Latin America(all income levels)?
Keep it short and to the point. 0.15. What is the ratio of the Rent(as % of GDP) of 1972 in High income: OECD to that in Latin America(all income levels)?
Make the answer very short. 0.15. What is the ratio of the Rent(as % of GDP) of 1973 in High income: OECD to that in Latin America(all income levels)?
Keep it short and to the point. 0.17. What is the ratio of the Rent(as % of GDP) in 1970 in High income: OECD to that in Latin America(developing only)?
Provide a succinct answer. 0.55. What is the ratio of the Rent(as % of GDP) in 1971 in High income: OECD to that in Latin America(developing only)?
Offer a very short reply. 0.54. What is the ratio of the Rent(as % of GDP) of 1972 in High income: OECD to that in Latin America(developing only)?
Your answer should be very brief. 0.49. What is the ratio of the Rent(as % of GDP) in 1973 in High income: OECD to that in Latin America(developing only)?
Offer a very short reply. 0.47. What is the ratio of the Rent(as % of GDP) in 1970 in Latin America(all income levels) to that in Latin America(developing only)?
Ensure brevity in your answer.  3.65. What is the ratio of the Rent(as % of GDP) of 1971 in Latin America(all income levels) to that in Latin America(developing only)?
Make the answer very short. 3.5. What is the ratio of the Rent(as % of GDP) in 1972 in Latin America(all income levels) to that in Latin America(developing only)?
Offer a very short reply. 3.19. What is the ratio of the Rent(as % of GDP) in 1973 in Latin America(all income levels) to that in Latin America(developing only)?
Provide a succinct answer. 2.85. What is the difference between the highest and the second highest Rent(as % of GDP) of 1970?
Keep it short and to the point. 0.78. What is the difference between the highest and the second highest Rent(as % of GDP) of 1971?
Keep it short and to the point. 0.96. What is the difference between the highest and the second highest Rent(as % of GDP) in 1972?
Give a very brief answer. 0.84. What is the difference between the highest and the second highest Rent(as % of GDP) of 1973?
Provide a succinct answer. 1.02. What is the difference between the highest and the lowest Rent(as % of GDP) of 1970?
Offer a terse response. 1.14. What is the difference between the highest and the lowest Rent(as % of GDP) of 1971?
Offer a terse response. 1.45. What is the difference between the highest and the lowest Rent(as % of GDP) of 1972?
Make the answer very short. 1.31. What is the difference between the highest and the lowest Rent(as % of GDP) of 1973?
Offer a terse response. 1.68. 